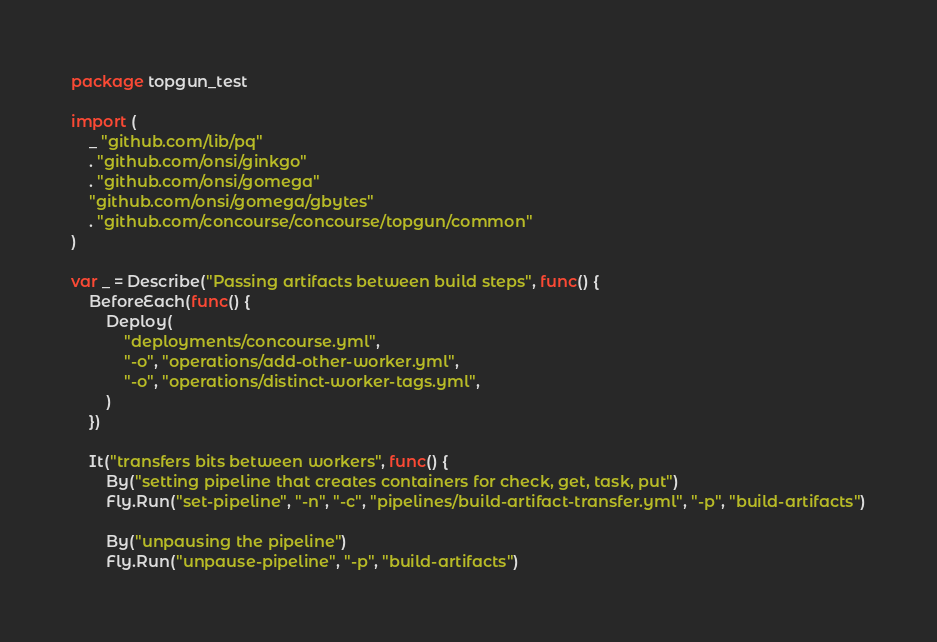Convert code to text. <code><loc_0><loc_0><loc_500><loc_500><_Go_>package topgun_test

import (
	_ "github.com/lib/pq"
	. "github.com/onsi/ginkgo"
	. "github.com/onsi/gomega"
	"github.com/onsi/gomega/gbytes"
	. "github.com/concourse/concourse/topgun/common"
)

var _ = Describe("Passing artifacts between build steps", func() {
	BeforeEach(func() {
		Deploy(
			"deployments/concourse.yml",
			"-o", "operations/add-other-worker.yml",
			"-o", "operations/distinct-worker-tags.yml",
		)
	})

	It("transfers bits between workers", func() {
		By("setting pipeline that creates containers for check, get, task, put")
		Fly.Run("set-pipeline", "-n", "-c", "pipelines/build-artifact-transfer.yml", "-p", "build-artifacts")

		By("unpausing the pipeline")
		Fly.Run("unpause-pipeline", "-p", "build-artifacts")
</code> 